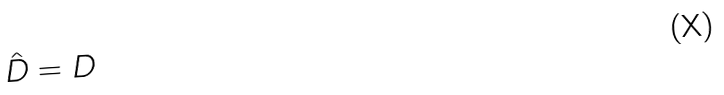<formula> <loc_0><loc_0><loc_500><loc_500>\hat { D } = D</formula> 